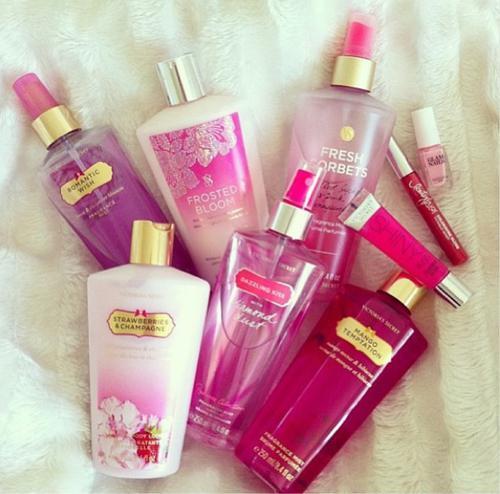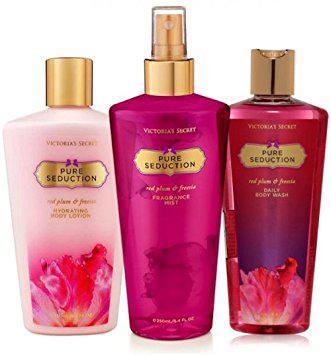The first image is the image on the left, the second image is the image on the right. Considering the images on both sides, is "More beauty products are pictured in the left image than in the right image." valid? Answer yes or no. Yes. The first image is the image on the left, the second image is the image on the right. Considering the images on both sides, is "The bottles in the left image are arranged on a white cloth background." valid? Answer yes or no. Yes. 